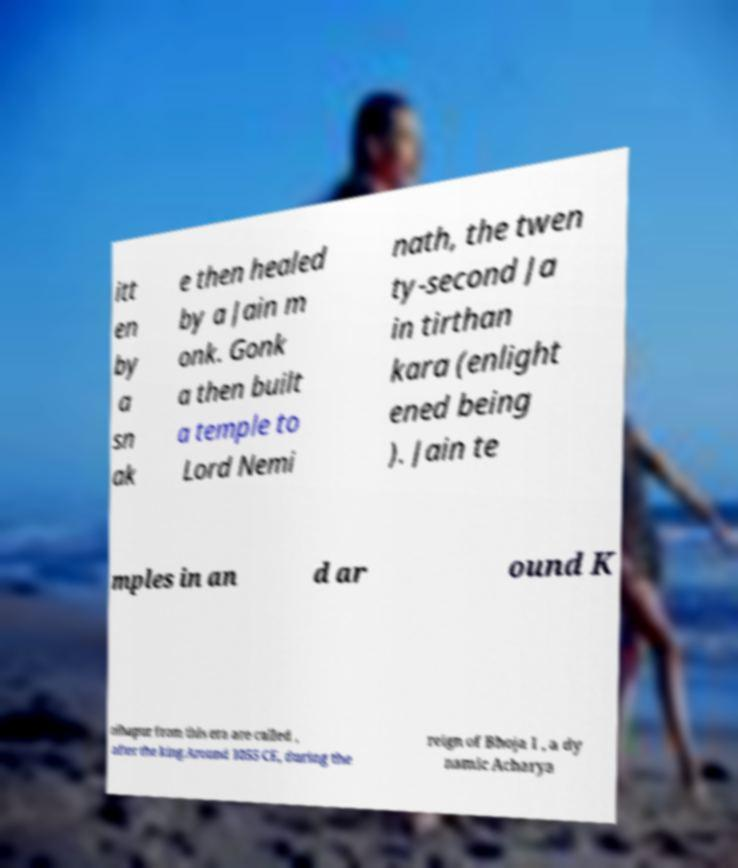Could you assist in decoding the text presented in this image and type it out clearly? itt en by a sn ak e then healed by a Jain m onk. Gonk a then built a temple to Lord Nemi nath, the twen ty-second Ja in tirthan kara (enlight ened being ). Jain te mples in an d ar ound K olhapur from this era are called , after the king.Around 1055 CE, during the reign of Bhoja I , a dy namic Acharya 